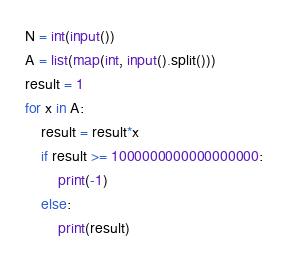<code> <loc_0><loc_0><loc_500><loc_500><_Python_>N = int(input())
A = list(map(int, input().split()))
result = 1
for x in A:
    result = result*x
    if result >= 1000000000000000000:
        print(-1)
    else:
        print(result)</code> 